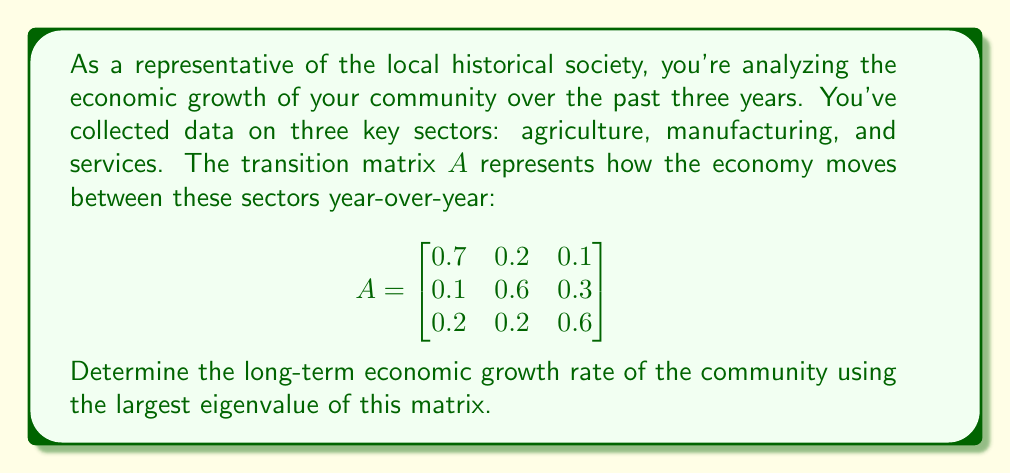What is the answer to this math problem? To find the long-term economic growth rate, we need to calculate the largest eigenvalue of the transition matrix $A$. This eigenvalue represents the dominant growth factor in the economy.

Step 1: Set up the characteristic equation
$\det(A - \lambda I) = 0$, where $I$ is the 3x3 identity matrix.

$$\det\begin{pmatrix}
0.7-\lambda & 0.2 & 0.1 \\
0.1 & 0.6-\lambda & 0.3 \\
0.2 & 0.2 & 0.6-\lambda
\end{pmatrix} = 0$$

Step 2: Expand the determinant
$(0.7-\lambda)[(0.6-\lambda)(0.6-\lambda)-0.06] - 0.2[0.1(0.6-\lambda)-0.3(0.2)] + 0.1[0.1(0.2)-0.3(0.6-\lambda)] = 0$

Step 3: Simplify
$-\lambda^3 + 1.9\lambda^2 - 1.14\lambda + 0.216 = 0$

Step 4: Solve the cubic equation
Using numerical methods or a computer algebra system, we find the roots:
$\lambda_1 \approx 1$
$\lambda_2 \approx 0.5$
$\lambda_3 \approx 0.4$

Step 5: Identify the largest eigenvalue
The largest eigenvalue is $\lambda_1 \approx 1$

Step 6: Calculate the growth rate
The growth rate is given by $(\lambda_1 - 1) \times 100\%$
$\approx (1 - 1) \times 100\% = 0\%$
Answer: The long-term economic growth rate of the community is approximately 0%. 